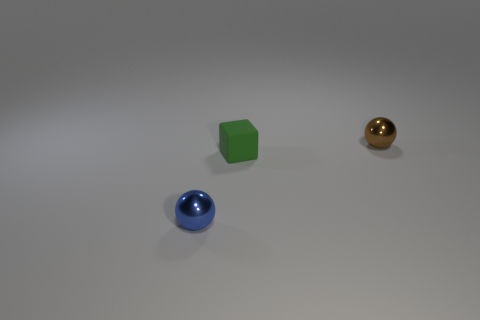There is a small object that is behind the blue sphere and in front of the brown shiny sphere; what is its shape?
Your answer should be compact. Cube. What is the size of the object that is the same material as the tiny blue ball?
Keep it short and to the point. Small. What number of things are tiny balls to the left of the tiny brown metallic sphere or small things that are to the right of the tiny blue ball?
Provide a succinct answer. 3. Is the size of the ball that is to the right of the blue thing the same as the tiny matte block?
Keep it short and to the point. Yes. What color is the tiny metallic object in front of the tiny brown thing?
Provide a succinct answer. Blue. There is another tiny object that is the same shape as the blue object; what is its color?
Make the answer very short. Brown. How many brown objects are on the left side of the tiny shiny thing that is on the left side of the metallic object that is behind the blue object?
Ensure brevity in your answer.  0. Are there any other things that have the same material as the green block?
Keep it short and to the point. No. Is the number of blue metal balls to the left of the green block less than the number of tiny metallic objects?
Offer a very short reply. Yes. How many balls have the same material as the tiny brown thing?
Give a very brief answer. 1. 